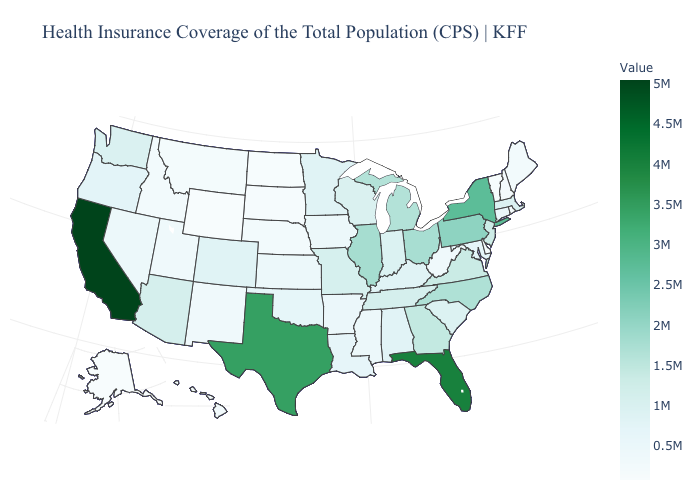Does Alaska have the lowest value in the West?
Give a very brief answer. Yes. Which states hav the highest value in the Northeast?
Quick response, please. New York. Which states hav the highest value in the MidWest?
Answer briefly. Illinois. Among the states that border Kentucky , which have the lowest value?
Quick response, please. West Virginia. Does the map have missing data?
Quick response, please. No. Which states have the highest value in the USA?
Keep it brief. California. Which states have the highest value in the USA?
Answer briefly. California. 